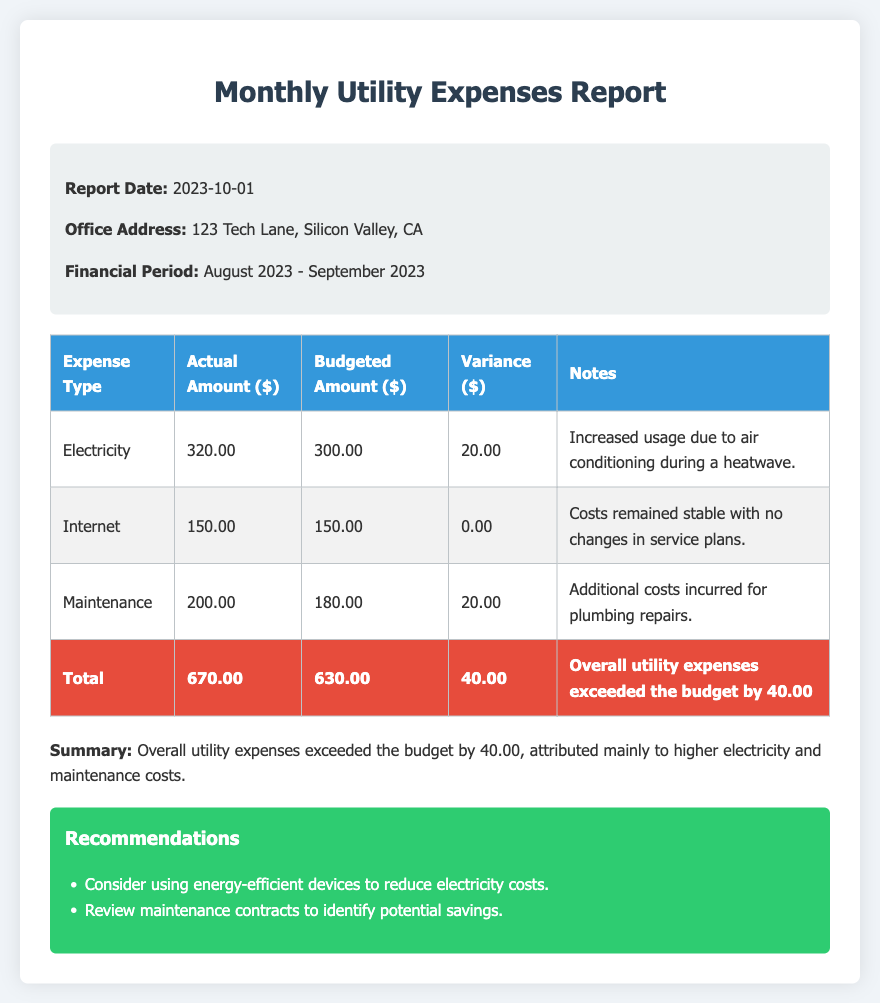What is the report date? The report date is specified in the info section as the date of the report generation.
Answer: 2023-10-01 What is the actual amount spent on electricity? The actual amount for electricity is noted in the expense table as the actual expense incurred for that category.
Answer: 320.00 What is the variance for maintenance costs? The variance for maintenance is calculated by subtracting the budgeted amount from the actual amount spent, as shown in the expense table.
Answer: 20.00 How much did the total utility expenses exceed the budget? The total variance at the bottom of the table represents how much overall expenses have exceeded the budgeted amounts.
Answer: 40.00 What recommendations were made to reduce costs? The recommendations section outlines suggestions for cost savings, focusing on energy efficiency and maintenance reviews.
Answer: Energy-efficient devices, review maintenance contracts What is the budgeted amount for internet? The budgeted amount for internet services is provided in the expense table under the budgeted amount column for internet.
Answer: 150.00 What additional costs were incurred for maintenance? Notes in the expense table specify the reason for the budget variance related to maintenance costs.
Answer: Plumbing repairs What was the total actual amount for all utility expenses? The total actual amount is the sum of all actual expenses listed in the table for each category.
Answer: 670.00 What type of document is this? The document is focused on the financial overview of utility expenses, as indicated in the title and structure of the content.
Answer: Financial Report 